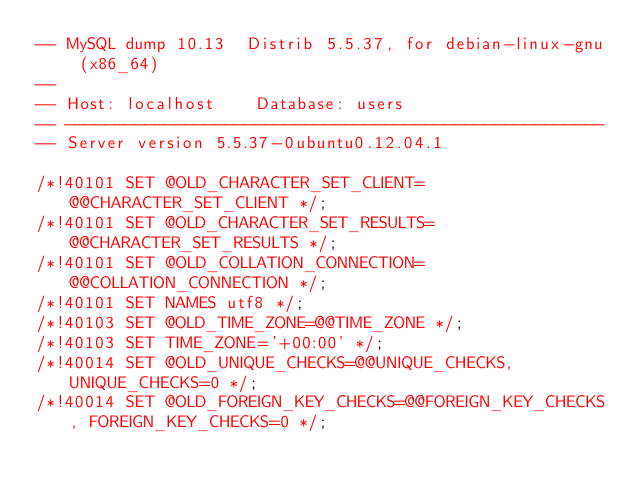<code> <loc_0><loc_0><loc_500><loc_500><_SQL_>-- MySQL dump 10.13  Distrib 5.5.37, for debian-linux-gnu (x86_64)
--
-- Host: localhost    Database: users
-- ------------------------------------------------------
-- Server version	5.5.37-0ubuntu0.12.04.1

/*!40101 SET @OLD_CHARACTER_SET_CLIENT=@@CHARACTER_SET_CLIENT */;
/*!40101 SET @OLD_CHARACTER_SET_RESULTS=@@CHARACTER_SET_RESULTS */;
/*!40101 SET @OLD_COLLATION_CONNECTION=@@COLLATION_CONNECTION */;
/*!40101 SET NAMES utf8 */;
/*!40103 SET @OLD_TIME_ZONE=@@TIME_ZONE */;
/*!40103 SET TIME_ZONE='+00:00' */;
/*!40014 SET @OLD_UNIQUE_CHECKS=@@UNIQUE_CHECKS, UNIQUE_CHECKS=0 */;
/*!40014 SET @OLD_FOREIGN_KEY_CHECKS=@@FOREIGN_KEY_CHECKS, FOREIGN_KEY_CHECKS=0 */;</code> 